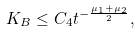Convert formula to latex. <formula><loc_0><loc_0><loc_500><loc_500>K _ { B } \leq C _ { 4 } t ^ { - \frac { \mu _ { 1 } + \mu _ { 2 } } 2 } ,</formula> 